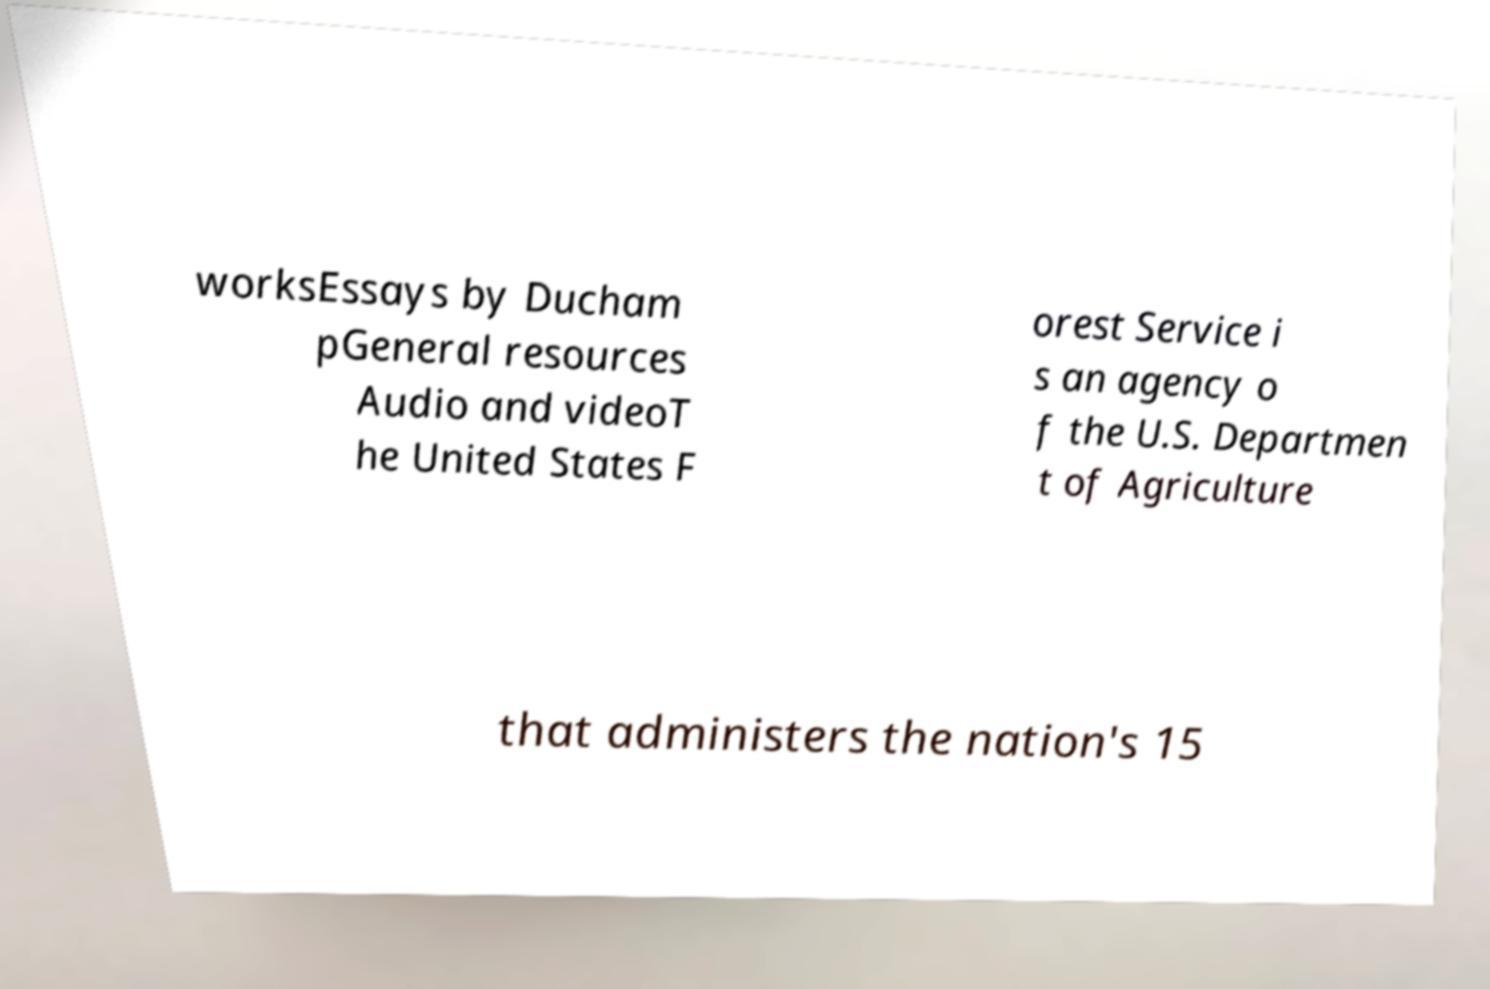Can you accurately transcribe the text from the provided image for me? worksEssays by Ducham pGeneral resources Audio and videoT he United States F orest Service i s an agency o f the U.S. Departmen t of Agriculture that administers the nation's 15 